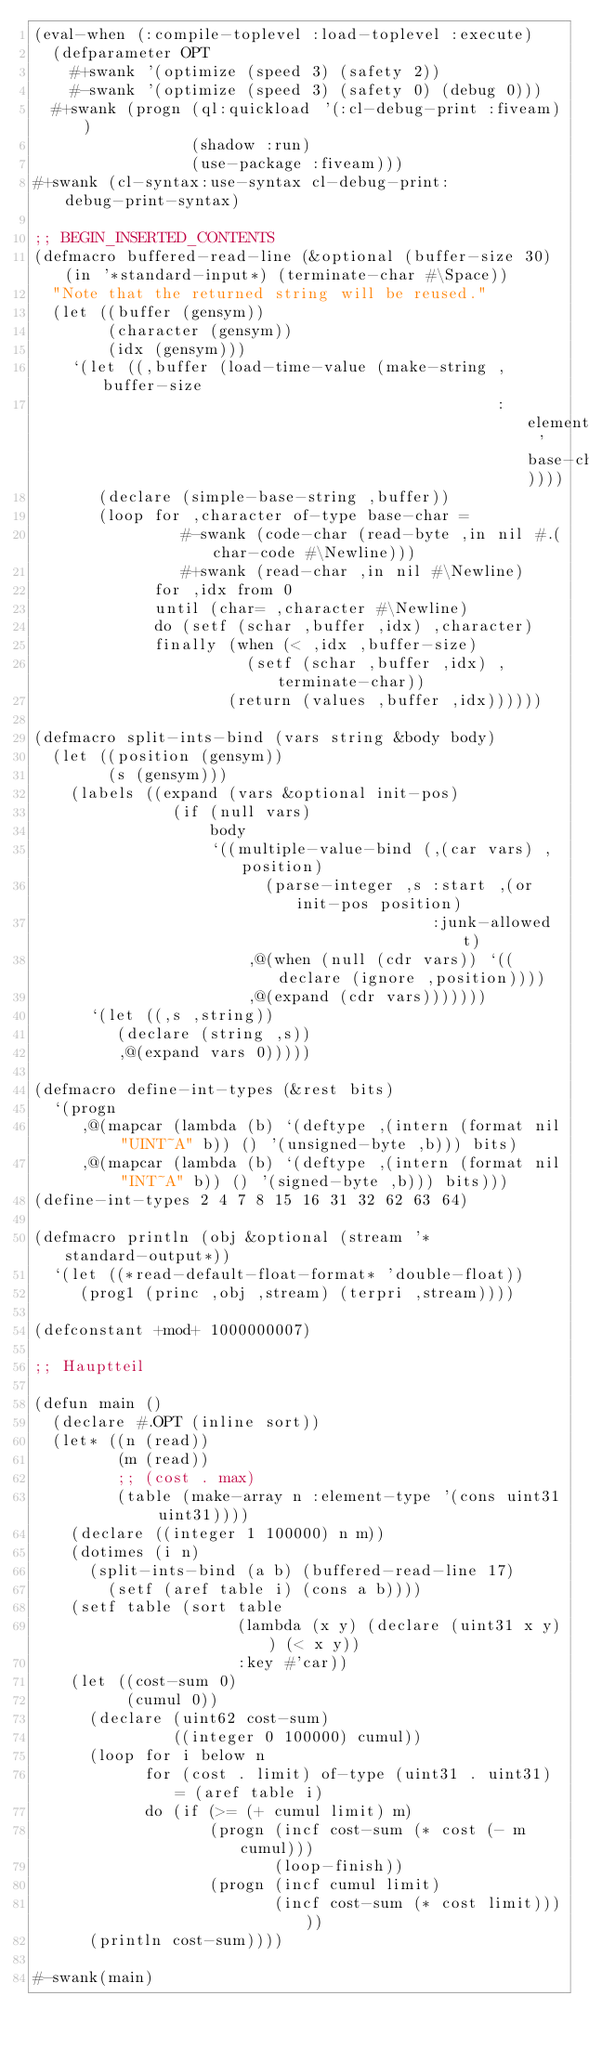<code> <loc_0><loc_0><loc_500><loc_500><_Lisp_>(eval-when (:compile-toplevel :load-toplevel :execute)
  (defparameter OPT
    #+swank '(optimize (speed 3) (safety 2))
    #-swank '(optimize (speed 3) (safety 0) (debug 0)))
  #+swank (progn (ql:quickload '(:cl-debug-print :fiveam))
                 (shadow :run)
                 (use-package :fiveam)))
#+swank (cl-syntax:use-syntax cl-debug-print:debug-print-syntax)

;; BEGIN_INSERTED_CONTENTS
(defmacro buffered-read-line (&optional (buffer-size 30) (in '*standard-input*) (terminate-char #\Space))
  "Note that the returned string will be reused."
  (let ((buffer (gensym))
        (character (gensym))
        (idx (gensym)))
    `(let ((,buffer (load-time-value (make-string ,buffer-size
                                                  :element-type 'base-char))))
       (declare (simple-base-string ,buffer))
       (loop for ,character of-type base-char =
                #-swank (code-char (read-byte ,in nil #.(char-code #\Newline)))
                #+swank (read-char ,in nil #\Newline)
             for ,idx from 0
             until (char= ,character #\Newline)
             do (setf (schar ,buffer ,idx) ,character)
             finally (when (< ,idx ,buffer-size)
                       (setf (schar ,buffer ,idx) ,terminate-char))
                     (return (values ,buffer ,idx))))))

(defmacro split-ints-bind (vars string &body body)
  (let ((position (gensym))
        (s (gensym)))
    (labels ((expand (vars &optional init-pos)
               (if (null vars)
                   body
                   `((multiple-value-bind (,(car vars) ,position)
                         (parse-integer ,s :start ,(or init-pos position)
                                           :junk-allowed t)
                       ,@(when (null (cdr vars)) `((declare (ignore ,position))))
                       ,@(expand (cdr vars)))))))
      `(let ((,s ,string))
         (declare (string ,s))
         ,@(expand vars 0)))))

(defmacro define-int-types (&rest bits)
  `(progn
     ,@(mapcar (lambda (b) `(deftype ,(intern (format nil "UINT~A" b)) () '(unsigned-byte ,b))) bits)
     ,@(mapcar (lambda (b) `(deftype ,(intern (format nil "INT~A" b)) () '(signed-byte ,b))) bits)))
(define-int-types 2 4 7 8 15 16 31 32 62 63 64)

(defmacro println (obj &optional (stream '*standard-output*))
  `(let ((*read-default-float-format* 'double-float))
     (prog1 (princ ,obj ,stream) (terpri ,stream))))

(defconstant +mod+ 1000000007)

;; Hauptteil

(defun main ()
  (declare #.OPT (inline sort))
  (let* ((n (read))
         (m (read))
         ;; (cost . max)
         (table (make-array n :element-type '(cons uint31 uint31))))
    (declare ((integer 1 100000) n m))
    (dotimes (i n)
      (split-ints-bind (a b) (buffered-read-line 17)
        (setf (aref table i) (cons a b))))
    (setf table (sort table
                      (lambda (x y) (declare (uint31 x y)) (< x y))
                      :key #'car))
    (let ((cost-sum 0)
          (cumul 0))
      (declare (uint62 cost-sum)
               ((integer 0 100000) cumul))
      (loop for i below n
            for (cost . limit) of-type (uint31 . uint31) = (aref table i)
            do (if (>= (+ cumul limit) m)
                   (progn (incf cost-sum (* cost (- m cumul)))
                          (loop-finish))
                   (progn (incf cumul limit)
                          (incf cost-sum (* cost limit)))))
      (println cost-sum))))

#-swank(main)
</code> 